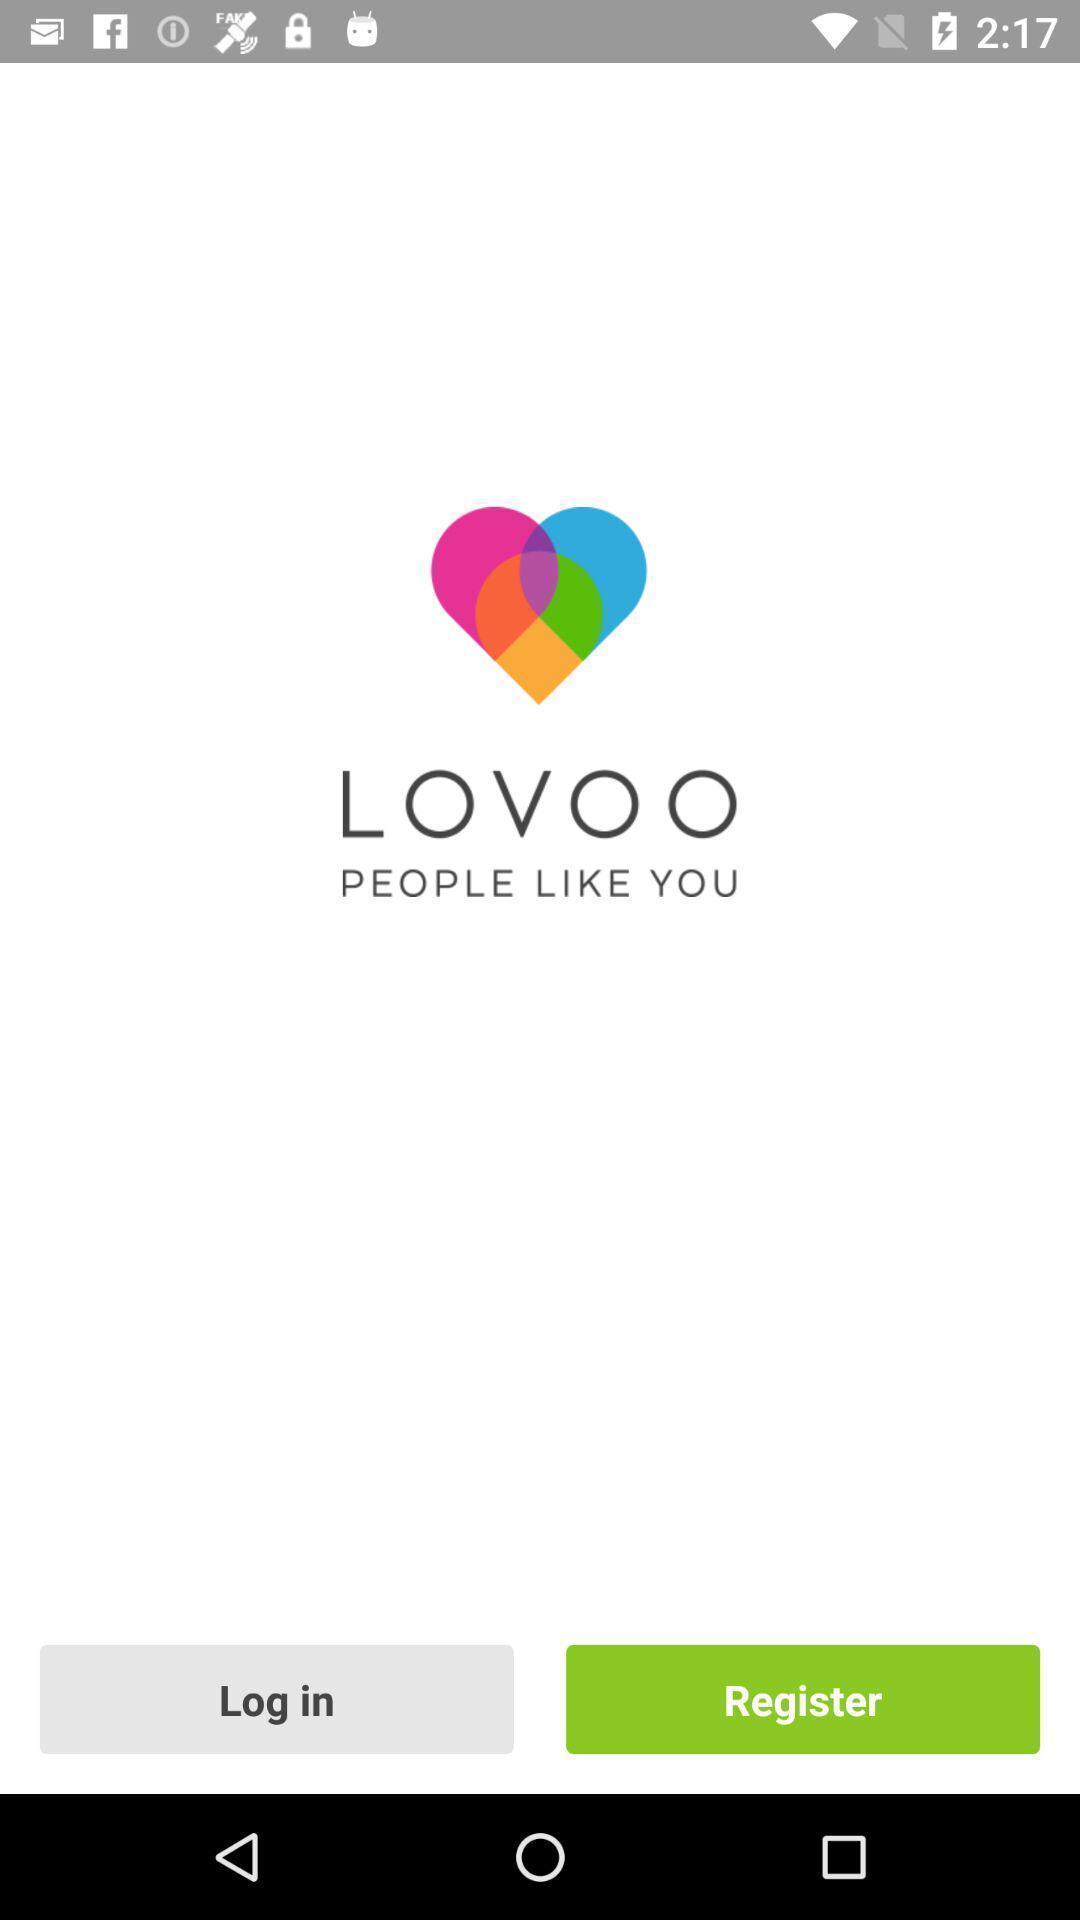What can you discern from this picture? Welcome screen of dating app. 